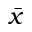Convert formula to latex. <formula><loc_0><loc_0><loc_500><loc_500>\bar { x }</formula> 